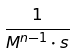<formula> <loc_0><loc_0><loc_500><loc_500>\frac { 1 } { M ^ { n - 1 } \cdot s }</formula> 